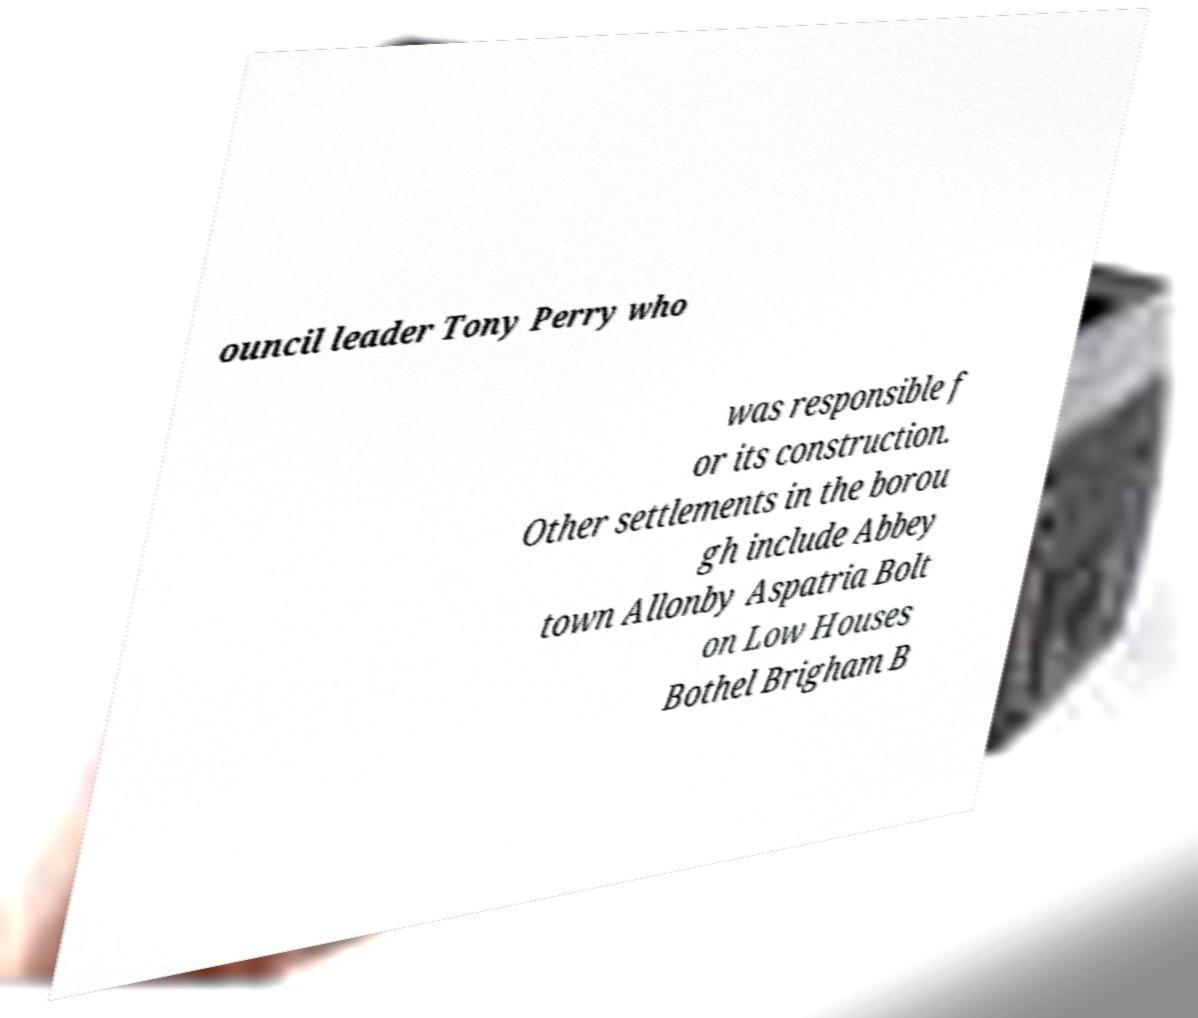For documentation purposes, I need the text within this image transcribed. Could you provide that? ouncil leader Tony Perry who was responsible f or its construction. Other settlements in the borou gh include Abbey town Allonby Aspatria Bolt on Low Houses Bothel Brigham B 